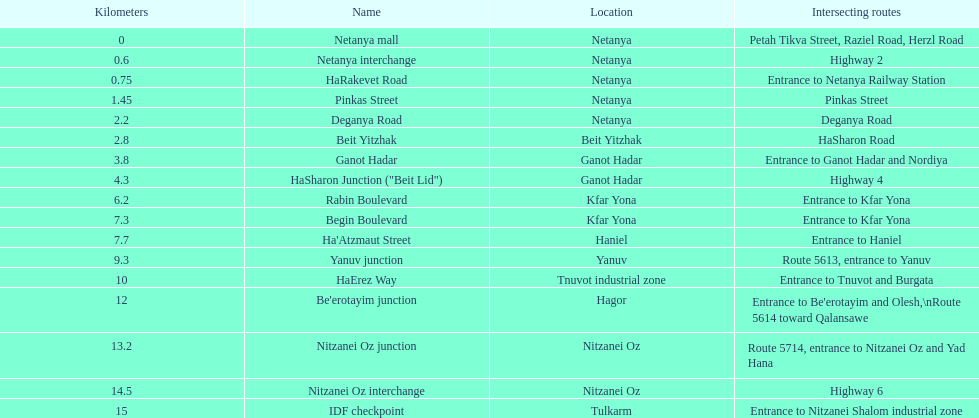How many sections can be found in netanya? 5. 